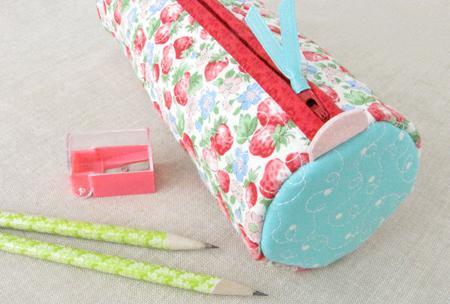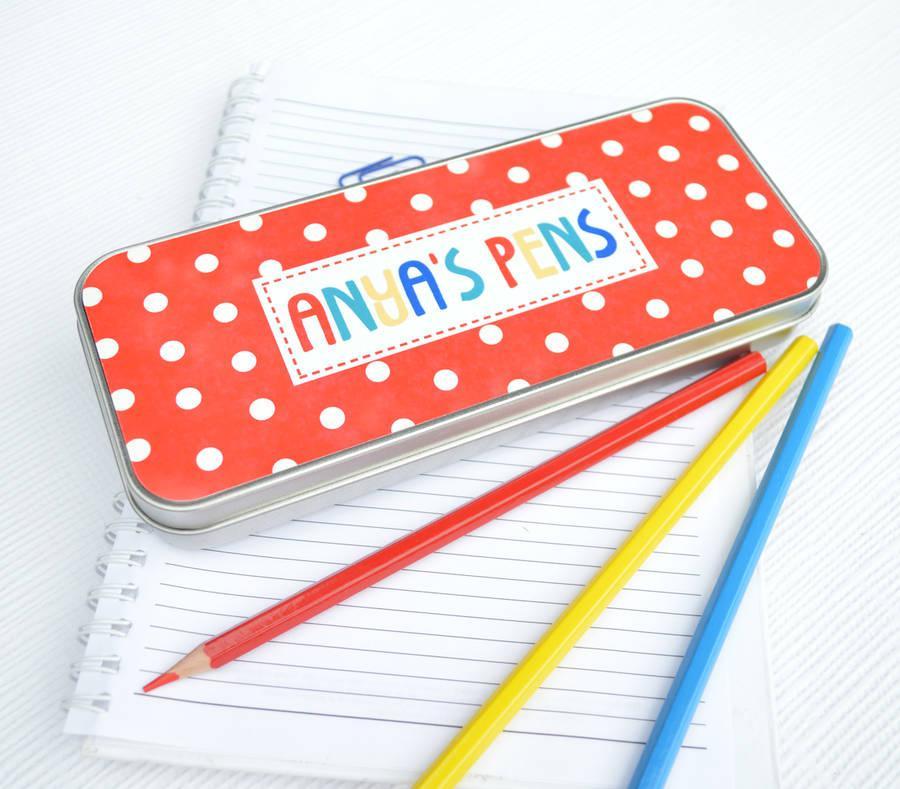The first image is the image on the left, the second image is the image on the right. Given the left and right images, does the statement "One image shows a pencil case lying on top of notepaper." hold true? Answer yes or no. Yes. The first image is the image on the left, the second image is the image on the right. Analyze the images presented: Is the assertion "There are strawberries pictured on a total of 1 pencil case." valid? Answer yes or no. Yes. 